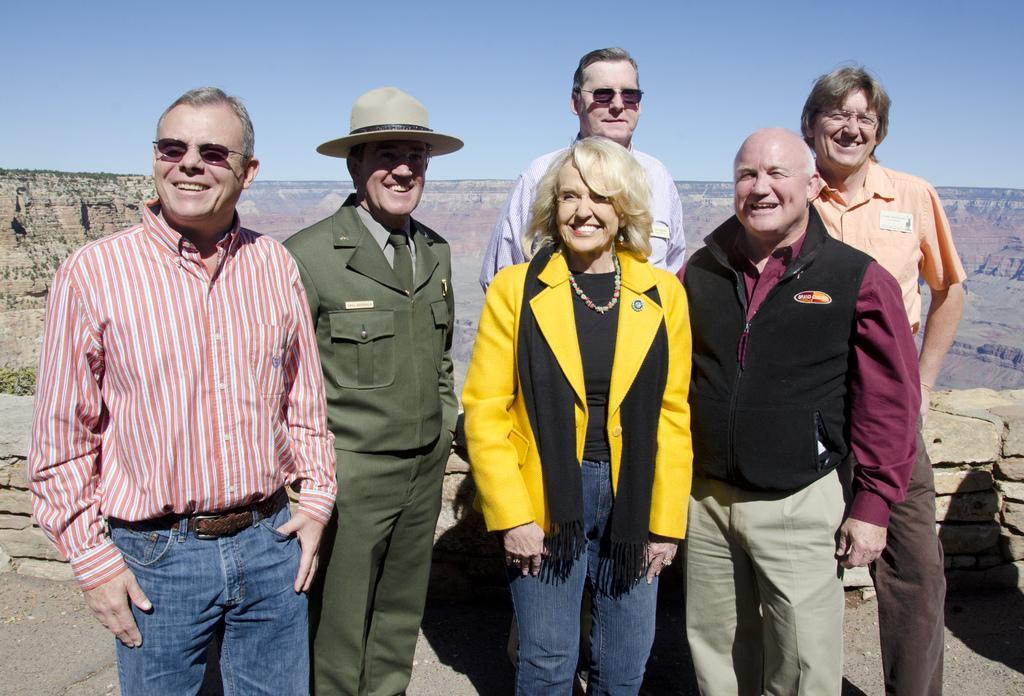Could you give a brief overview of what you see in this image? This image is taken outdoors. At the top of the image there is the sky. In the background there are a few rocks. At the bottom of the image there is a road. In the middle of the image five men and a woman are standing on the road and they are with smiling faces. 